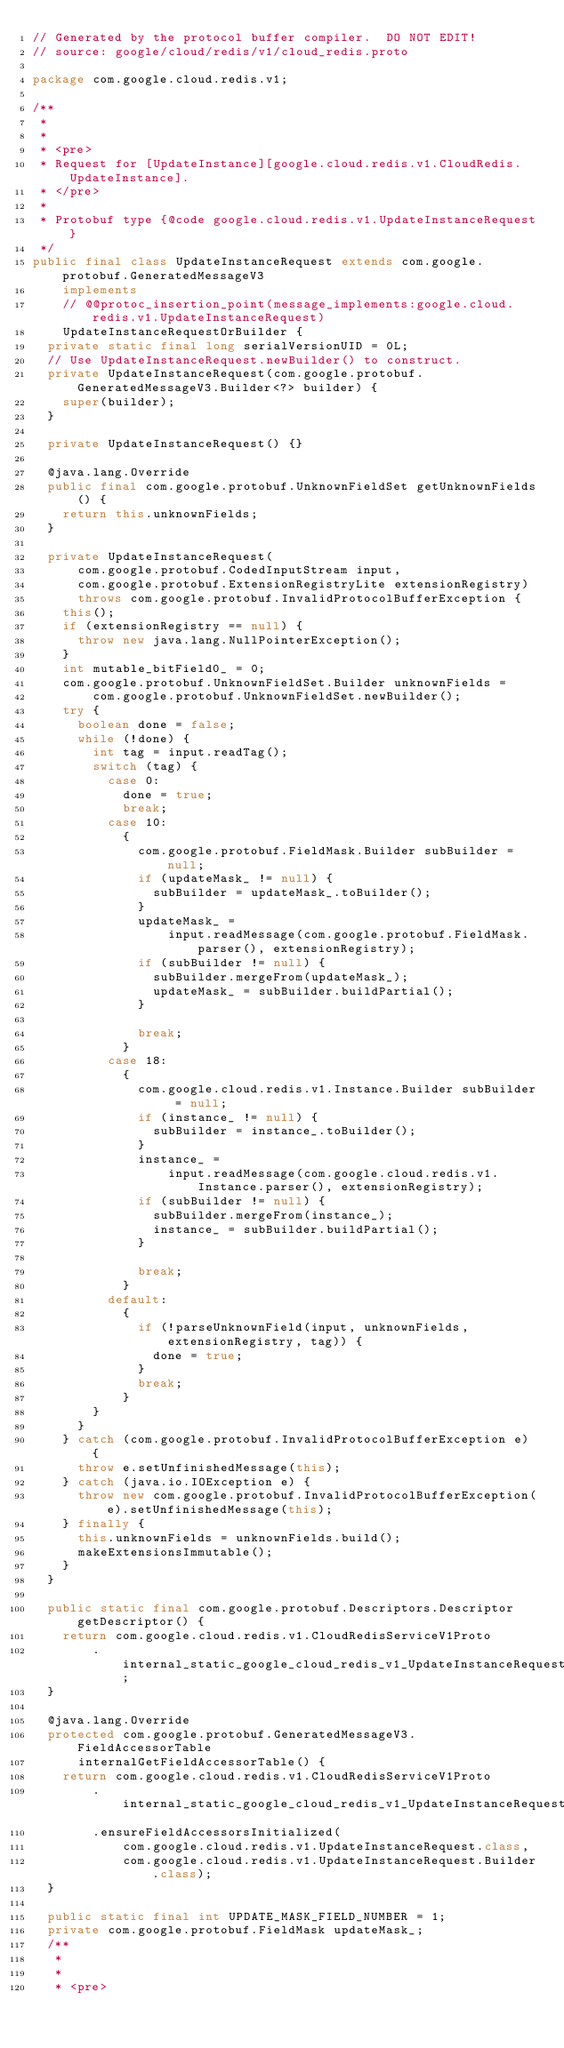<code> <loc_0><loc_0><loc_500><loc_500><_Java_>// Generated by the protocol buffer compiler.  DO NOT EDIT!
// source: google/cloud/redis/v1/cloud_redis.proto

package com.google.cloud.redis.v1;

/**
 *
 *
 * <pre>
 * Request for [UpdateInstance][google.cloud.redis.v1.CloudRedis.UpdateInstance].
 * </pre>
 *
 * Protobuf type {@code google.cloud.redis.v1.UpdateInstanceRequest}
 */
public final class UpdateInstanceRequest extends com.google.protobuf.GeneratedMessageV3
    implements
    // @@protoc_insertion_point(message_implements:google.cloud.redis.v1.UpdateInstanceRequest)
    UpdateInstanceRequestOrBuilder {
  private static final long serialVersionUID = 0L;
  // Use UpdateInstanceRequest.newBuilder() to construct.
  private UpdateInstanceRequest(com.google.protobuf.GeneratedMessageV3.Builder<?> builder) {
    super(builder);
  }

  private UpdateInstanceRequest() {}

  @java.lang.Override
  public final com.google.protobuf.UnknownFieldSet getUnknownFields() {
    return this.unknownFields;
  }

  private UpdateInstanceRequest(
      com.google.protobuf.CodedInputStream input,
      com.google.protobuf.ExtensionRegistryLite extensionRegistry)
      throws com.google.protobuf.InvalidProtocolBufferException {
    this();
    if (extensionRegistry == null) {
      throw new java.lang.NullPointerException();
    }
    int mutable_bitField0_ = 0;
    com.google.protobuf.UnknownFieldSet.Builder unknownFields =
        com.google.protobuf.UnknownFieldSet.newBuilder();
    try {
      boolean done = false;
      while (!done) {
        int tag = input.readTag();
        switch (tag) {
          case 0:
            done = true;
            break;
          case 10:
            {
              com.google.protobuf.FieldMask.Builder subBuilder = null;
              if (updateMask_ != null) {
                subBuilder = updateMask_.toBuilder();
              }
              updateMask_ =
                  input.readMessage(com.google.protobuf.FieldMask.parser(), extensionRegistry);
              if (subBuilder != null) {
                subBuilder.mergeFrom(updateMask_);
                updateMask_ = subBuilder.buildPartial();
              }

              break;
            }
          case 18:
            {
              com.google.cloud.redis.v1.Instance.Builder subBuilder = null;
              if (instance_ != null) {
                subBuilder = instance_.toBuilder();
              }
              instance_ =
                  input.readMessage(com.google.cloud.redis.v1.Instance.parser(), extensionRegistry);
              if (subBuilder != null) {
                subBuilder.mergeFrom(instance_);
                instance_ = subBuilder.buildPartial();
              }

              break;
            }
          default:
            {
              if (!parseUnknownField(input, unknownFields, extensionRegistry, tag)) {
                done = true;
              }
              break;
            }
        }
      }
    } catch (com.google.protobuf.InvalidProtocolBufferException e) {
      throw e.setUnfinishedMessage(this);
    } catch (java.io.IOException e) {
      throw new com.google.protobuf.InvalidProtocolBufferException(e).setUnfinishedMessage(this);
    } finally {
      this.unknownFields = unknownFields.build();
      makeExtensionsImmutable();
    }
  }

  public static final com.google.protobuf.Descriptors.Descriptor getDescriptor() {
    return com.google.cloud.redis.v1.CloudRedisServiceV1Proto
        .internal_static_google_cloud_redis_v1_UpdateInstanceRequest_descriptor;
  }

  @java.lang.Override
  protected com.google.protobuf.GeneratedMessageV3.FieldAccessorTable
      internalGetFieldAccessorTable() {
    return com.google.cloud.redis.v1.CloudRedisServiceV1Proto
        .internal_static_google_cloud_redis_v1_UpdateInstanceRequest_fieldAccessorTable
        .ensureFieldAccessorsInitialized(
            com.google.cloud.redis.v1.UpdateInstanceRequest.class,
            com.google.cloud.redis.v1.UpdateInstanceRequest.Builder.class);
  }

  public static final int UPDATE_MASK_FIELD_NUMBER = 1;
  private com.google.protobuf.FieldMask updateMask_;
  /**
   *
   *
   * <pre></code> 